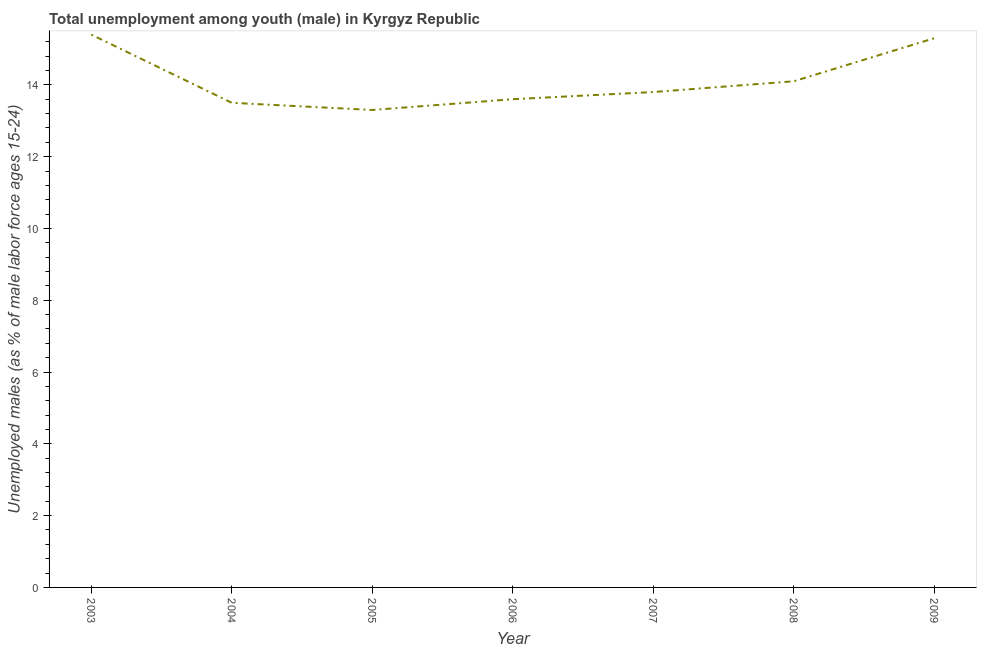What is the unemployed male youth population in 2005?
Your response must be concise. 13.3. Across all years, what is the maximum unemployed male youth population?
Your answer should be compact. 15.4. Across all years, what is the minimum unemployed male youth population?
Make the answer very short. 13.3. In which year was the unemployed male youth population maximum?
Make the answer very short. 2003. In which year was the unemployed male youth population minimum?
Offer a terse response. 2005. What is the sum of the unemployed male youth population?
Give a very brief answer. 99. What is the difference between the unemployed male youth population in 2003 and 2008?
Offer a very short reply. 1.3. What is the average unemployed male youth population per year?
Offer a very short reply. 14.14. What is the median unemployed male youth population?
Your answer should be compact. 13.8. In how many years, is the unemployed male youth population greater than 12 %?
Provide a short and direct response. 7. What is the ratio of the unemployed male youth population in 2005 to that in 2009?
Make the answer very short. 0.87. Is the unemployed male youth population in 2003 less than that in 2005?
Your answer should be compact. No. Is the difference between the unemployed male youth population in 2006 and 2009 greater than the difference between any two years?
Ensure brevity in your answer.  No. What is the difference between the highest and the second highest unemployed male youth population?
Give a very brief answer. 0.1. Is the sum of the unemployed male youth population in 2005 and 2009 greater than the maximum unemployed male youth population across all years?
Keep it short and to the point. Yes. What is the difference between the highest and the lowest unemployed male youth population?
Offer a terse response. 2.1. How many lines are there?
Your response must be concise. 1. How many years are there in the graph?
Give a very brief answer. 7. Does the graph contain grids?
Your answer should be compact. No. What is the title of the graph?
Your answer should be very brief. Total unemployment among youth (male) in Kyrgyz Republic. What is the label or title of the X-axis?
Your answer should be very brief. Year. What is the label or title of the Y-axis?
Offer a very short reply. Unemployed males (as % of male labor force ages 15-24). What is the Unemployed males (as % of male labor force ages 15-24) of 2003?
Provide a short and direct response. 15.4. What is the Unemployed males (as % of male labor force ages 15-24) in 2005?
Ensure brevity in your answer.  13.3. What is the Unemployed males (as % of male labor force ages 15-24) in 2006?
Keep it short and to the point. 13.6. What is the Unemployed males (as % of male labor force ages 15-24) in 2007?
Offer a very short reply. 13.8. What is the Unemployed males (as % of male labor force ages 15-24) in 2008?
Give a very brief answer. 14.1. What is the Unemployed males (as % of male labor force ages 15-24) in 2009?
Give a very brief answer. 15.3. What is the difference between the Unemployed males (as % of male labor force ages 15-24) in 2003 and 2004?
Ensure brevity in your answer.  1.9. What is the difference between the Unemployed males (as % of male labor force ages 15-24) in 2003 and 2006?
Provide a short and direct response. 1.8. What is the difference between the Unemployed males (as % of male labor force ages 15-24) in 2003 and 2008?
Ensure brevity in your answer.  1.3. What is the difference between the Unemployed males (as % of male labor force ages 15-24) in 2004 and 2006?
Offer a terse response. -0.1. What is the difference between the Unemployed males (as % of male labor force ages 15-24) in 2004 and 2009?
Your answer should be very brief. -1.8. What is the difference between the Unemployed males (as % of male labor force ages 15-24) in 2005 and 2006?
Make the answer very short. -0.3. What is the difference between the Unemployed males (as % of male labor force ages 15-24) in 2005 and 2007?
Give a very brief answer. -0.5. What is the difference between the Unemployed males (as % of male labor force ages 15-24) in 2005 and 2008?
Keep it short and to the point. -0.8. What is the difference between the Unemployed males (as % of male labor force ages 15-24) in 2006 and 2009?
Ensure brevity in your answer.  -1.7. What is the difference between the Unemployed males (as % of male labor force ages 15-24) in 2008 and 2009?
Your response must be concise. -1.2. What is the ratio of the Unemployed males (as % of male labor force ages 15-24) in 2003 to that in 2004?
Ensure brevity in your answer.  1.14. What is the ratio of the Unemployed males (as % of male labor force ages 15-24) in 2003 to that in 2005?
Your answer should be compact. 1.16. What is the ratio of the Unemployed males (as % of male labor force ages 15-24) in 2003 to that in 2006?
Make the answer very short. 1.13. What is the ratio of the Unemployed males (as % of male labor force ages 15-24) in 2003 to that in 2007?
Provide a succinct answer. 1.12. What is the ratio of the Unemployed males (as % of male labor force ages 15-24) in 2003 to that in 2008?
Offer a very short reply. 1.09. What is the ratio of the Unemployed males (as % of male labor force ages 15-24) in 2004 to that in 2005?
Give a very brief answer. 1.01. What is the ratio of the Unemployed males (as % of male labor force ages 15-24) in 2004 to that in 2006?
Provide a succinct answer. 0.99. What is the ratio of the Unemployed males (as % of male labor force ages 15-24) in 2004 to that in 2008?
Your response must be concise. 0.96. What is the ratio of the Unemployed males (as % of male labor force ages 15-24) in 2004 to that in 2009?
Ensure brevity in your answer.  0.88. What is the ratio of the Unemployed males (as % of male labor force ages 15-24) in 2005 to that in 2008?
Ensure brevity in your answer.  0.94. What is the ratio of the Unemployed males (as % of male labor force ages 15-24) in 2005 to that in 2009?
Keep it short and to the point. 0.87. What is the ratio of the Unemployed males (as % of male labor force ages 15-24) in 2006 to that in 2007?
Your response must be concise. 0.99. What is the ratio of the Unemployed males (as % of male labor force ages 15-24) in 2006 to that in 2008?
Your response must be concise. 0.96. What is the ratio of the Unemployed males (as % of male labor force ages 15-24) in 2006 to that in 2009?
Offer a very short reply. 0.89. What is the ratio of the Unemployed males (as % of male labor force ages 15-24) in 2007 to that in 2009?
Your response must be concise. 0.9. What is the ratio of the Unemployed males (as % of male labor force ages 15-24) in 2008 to that in 2009?
Ensure brevity in your answer.  0.92. 